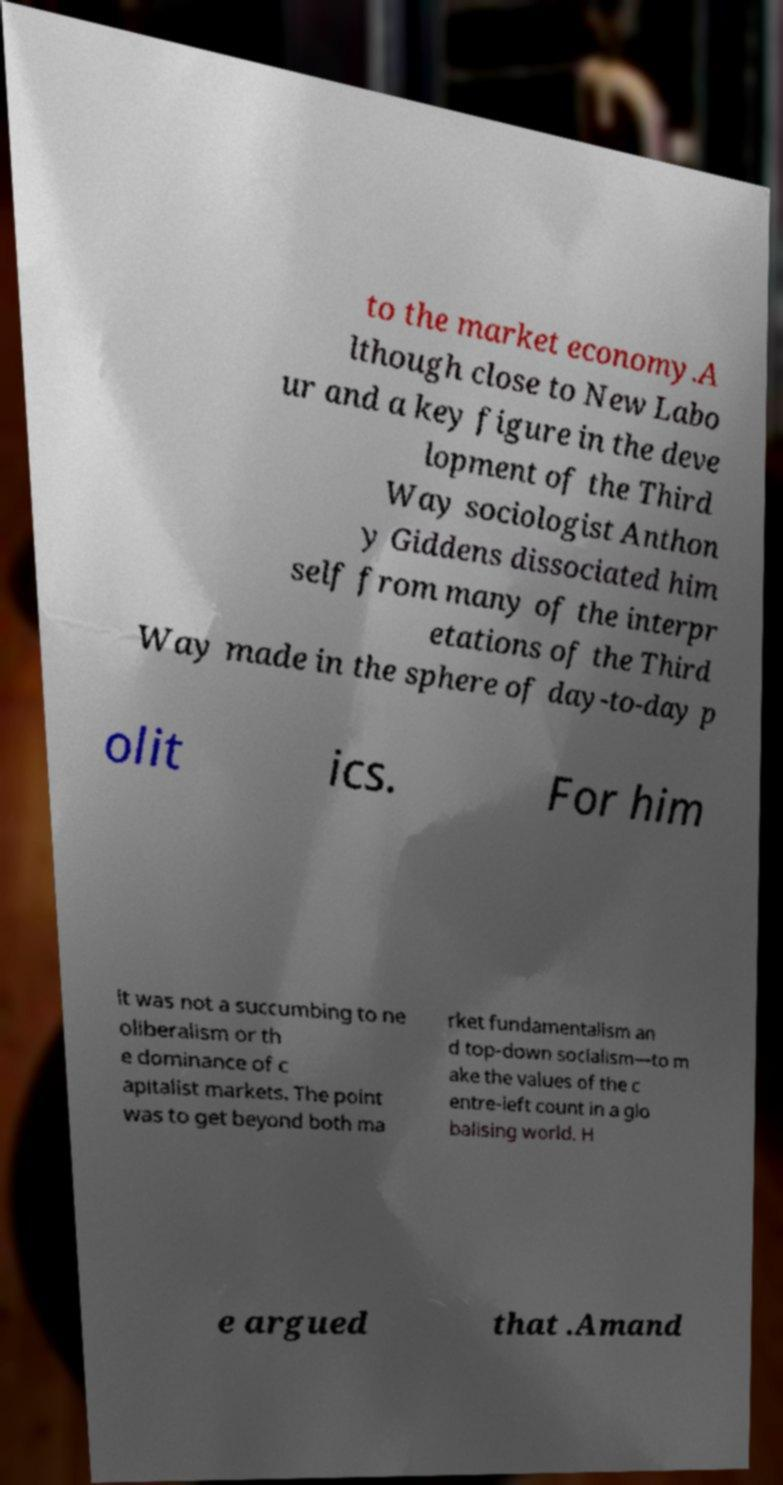Can you read and provide the text displayed in the image?This photo seems to have some interesting text. Can you extract and type it out for me? to the market economy.A lthough close to New Labo ur and a key figure in the deve lopment of the Third Way sociologist Anthon y Giddens dissociated him self from many of the interpr etations of the Third Way made in the sphere of day-to-day p olit ics. For him it was not a succumbing to ne oliberalism or th e dominance of c apitalist markets. The point was to get beyond both ma rket fundamentalism an d top-down socialism—to m ake the values of the c entre-left count in a glo balising world. H e argued that .Amand 